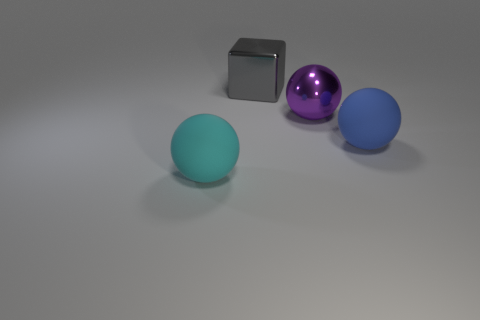Add 2 big blue matte objects. How many objects exist? 6 Subtract all spheres. How many objects are left? 1 Add 1 large shiny blocks. How many large shiny blocks exist? 2 Subtract 0 green cylinders. How many objects are left? 4 Subtract all blue things. Subtract all matte things. How many objects are left? 1 Add 1 rubber objects. How many rubber objects are left? 3 